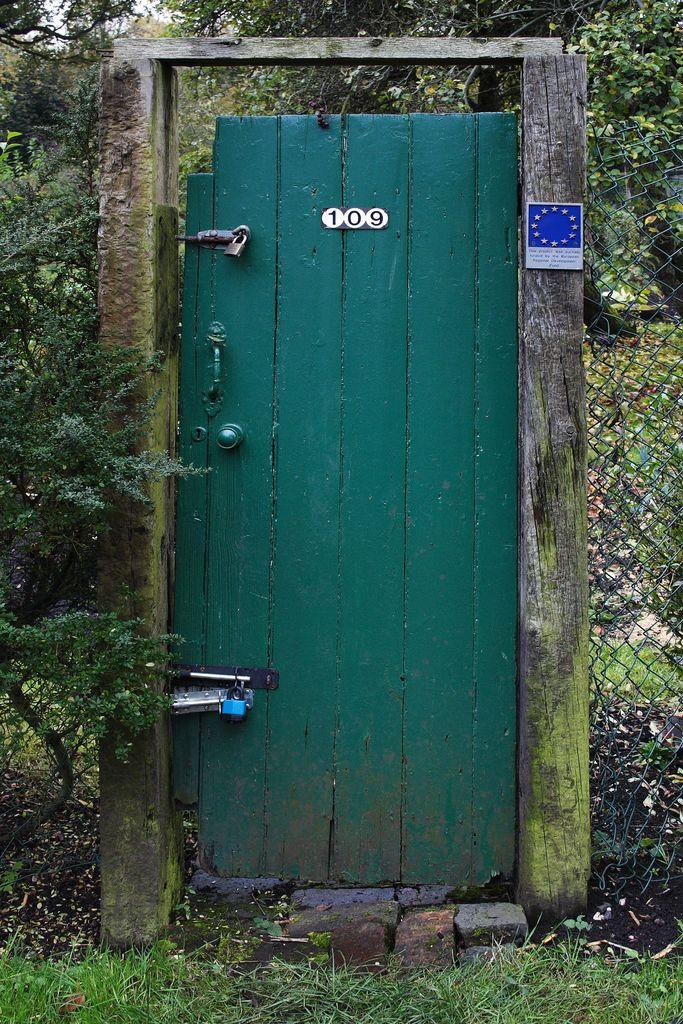What type of ground surface is visible in the image? There is grass on the ground in the image. What color is the door in the image? The door in the image is green. What can be seen in the background of the image? There are trees and the sky visible in the background of the image. Can you tell me how many yaks are grazing in the grass in the image? There are no yaks present in the image; it features grass, a green door, trees, and the sky. What is the wish of the person in the image? There is no person present in the image, so it is not possible to determine their wish. 